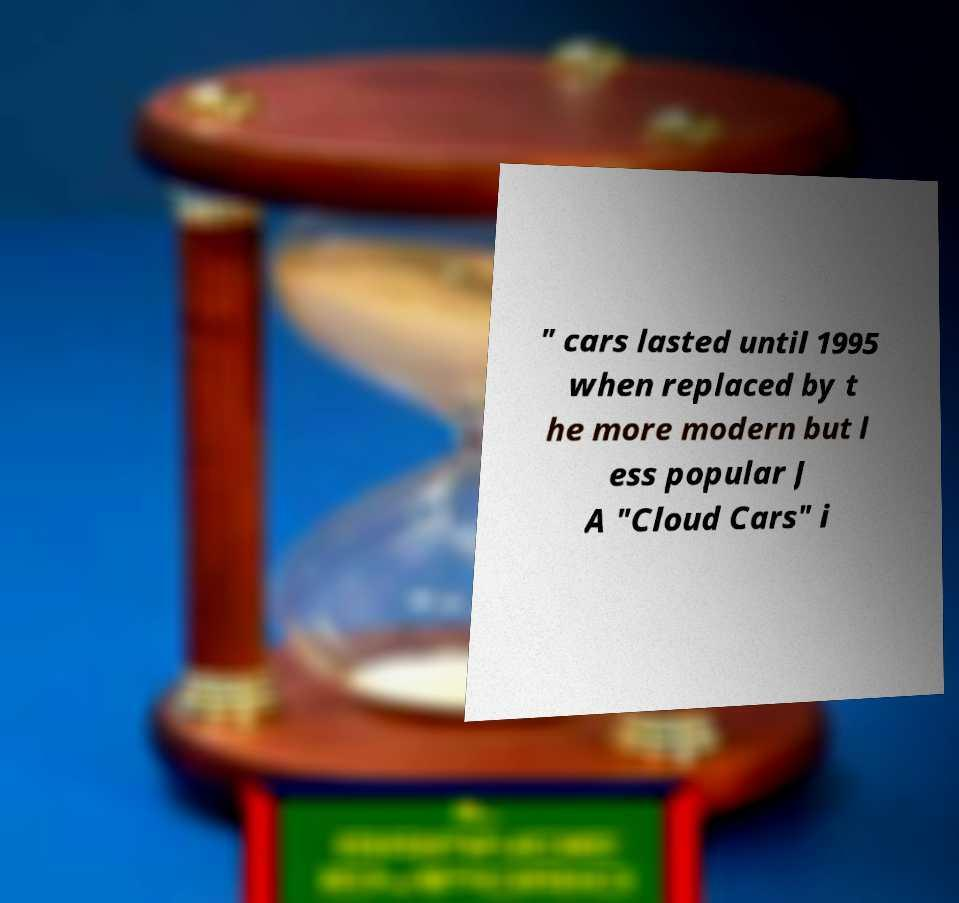Please read and relay the text visible in this image. What does it say? " cars lasted until 1995 when replaced by t he more modern but l ess popular J A "Cloud Cars" i 